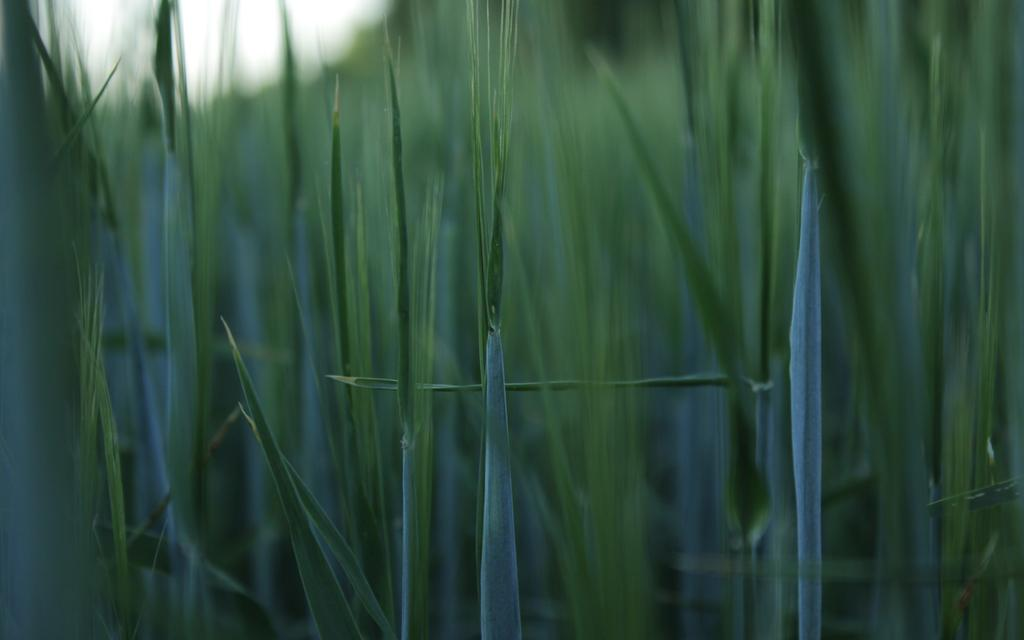What type of vegetation is visible in the image? There is grass in the image. What type of home can be seen in the background of the image? There is no home visible in the image; it only features grass. What type of sail is present in the image? There is no sail present in the image; it only features grass. 